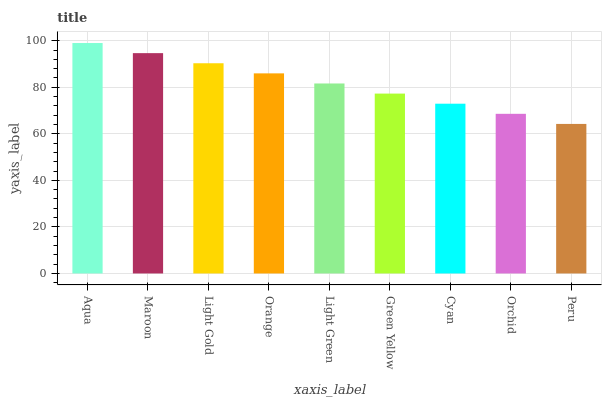Is Peru the minimum?
Answer yes or no. Yes. Is Aqua the maximum?
Answer yes or no. Yes. Is Maroon the minimum?
Answer yes or no. No. Is Maroon the maximum?
Answer yes or no. No. Is Aqua greater than Maroon?
Answer yes or no. Yes. Is Maroon less than Aqua?
Answer yes or no. Yes. Is Maroon greater than Aqua?
Answer yes or no. No. Is Aqua less than Maroon?
Answer yes or no. No. Is Light Green the high median?
Answer yes or no. Yes. Is Light Green the low median?
Answer yes or no. Yes. Is Orange the high median?
Answer yes or no. No. Is Light Gold the low median?
Answer yes or no. No. 